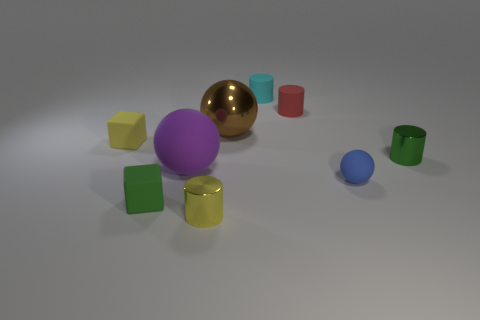Is there any other thing of the same color as the large matte object?
Make the answer very short. No. Is the material of the tiny blue thing the same as the green thing that is left of the cyan cylinder?
Offer a terse response. Yes. There is a tiny green thing on the left side of the cylinder that is in front of the small blue matte sphere; what is its shape?
Make the answer very short. Cube. What is the shape of the tiny matte object that is both to the left of the tiny red rubber cylinder and to the right of the green rubber object?
Offer a very short reply. Cylinder. How many objects are yellow objects or small cyan objects to the right of the yellow cube?
Offer a very short reply. 3. There is a green object that is the same shape as the tiny red thing; what is it made of?
Offer a terse response. Metal. Are there any other things that are the same material as the big purple object?
Your response must be concise. Yes. What material is the thing that is in front of the tiny blue ball and on the right side of the tiny green matte block?
Offer a very short reply. Metal. How many yellow shiny objects have the same shape as the blue object?
Ensure brevity in your answer.  0. What color is the tiny metal cylinder right of the big ball that is to the right of the yellow cylinder?
Offer a terse response. Green. 